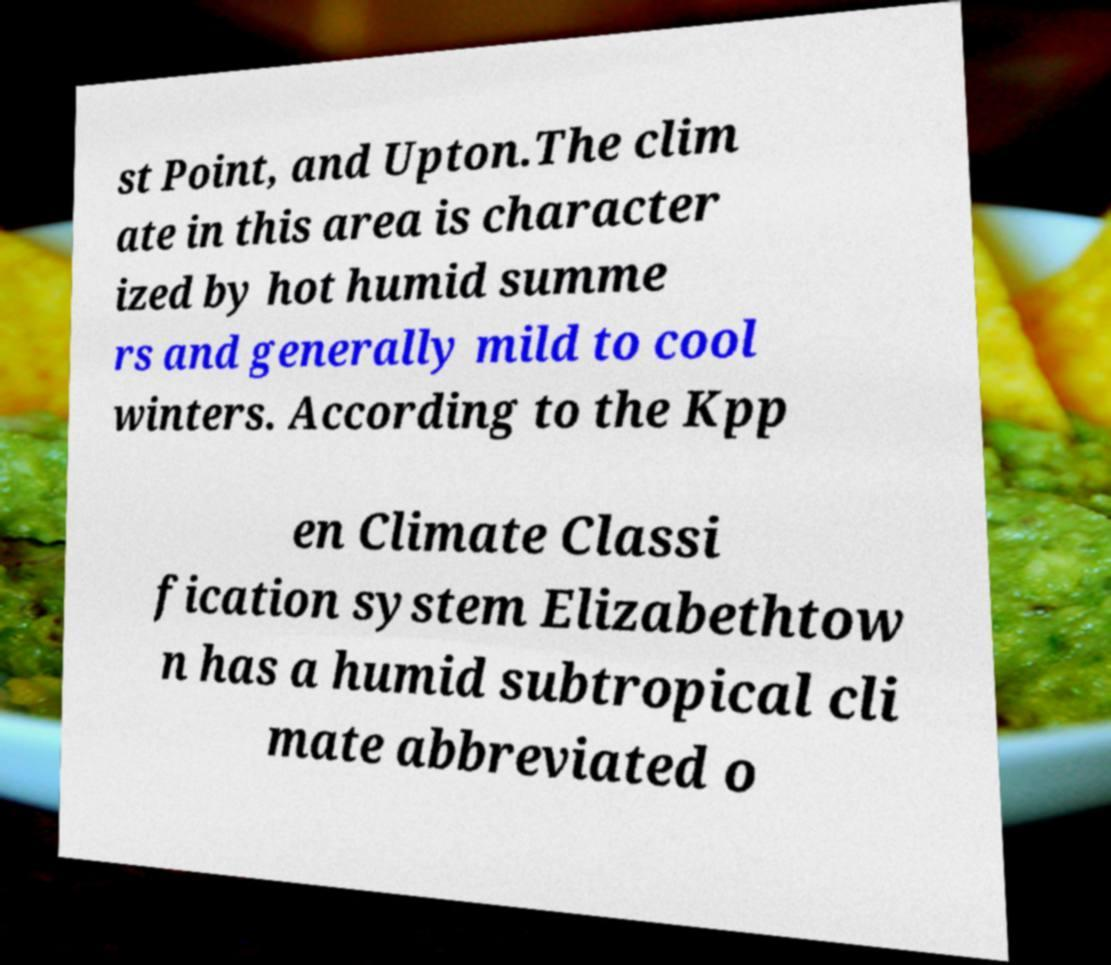Can you accurately transcribe the text from the provided image for me? st Point, and Upton.The clim ate in this area is character ized by hot humid summe rs and generally mild to cool winters. According to the Kpp en Climate Classi fication system Elizabethtow n has a humid subtropical cli mate abbreviated o 